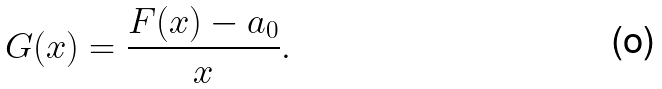<formula> <loc_0><loc_0><loc_500><loc_500>G ( x ) = \frac { F ( x ) - a _ { 0 } } { x } .</formula> 